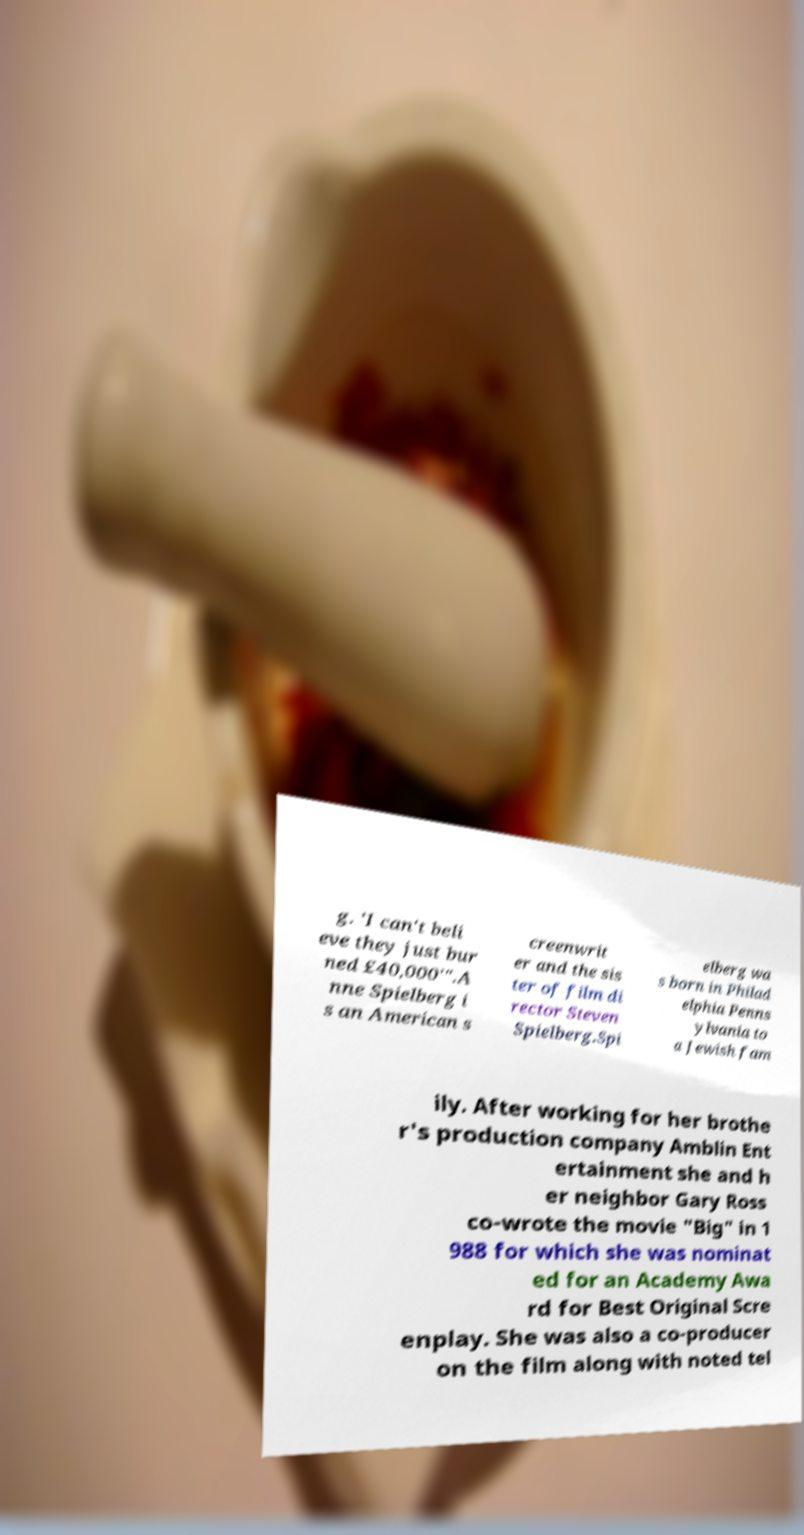Can you accurately transcribe the text from the provided image for me? g. 'I can't beli eve they just bur ned £40,000'".A nne Spielberg i s an American s creenwrit er and the sis ter of film di rector Steven Spielberg.Spi elberg wa s born in Philad elphia Penns ylvania to a Jewish fam ily. After working for her brothe r's production company Amblin Ent ertainment she and h er neighbor Gary Ross co-wrote the movie "Big" in 1 988 for which she was nominat ed for an Academy Awa rd for Best Original Scre enplay. She was also a co-producer on the film along with noted tel 